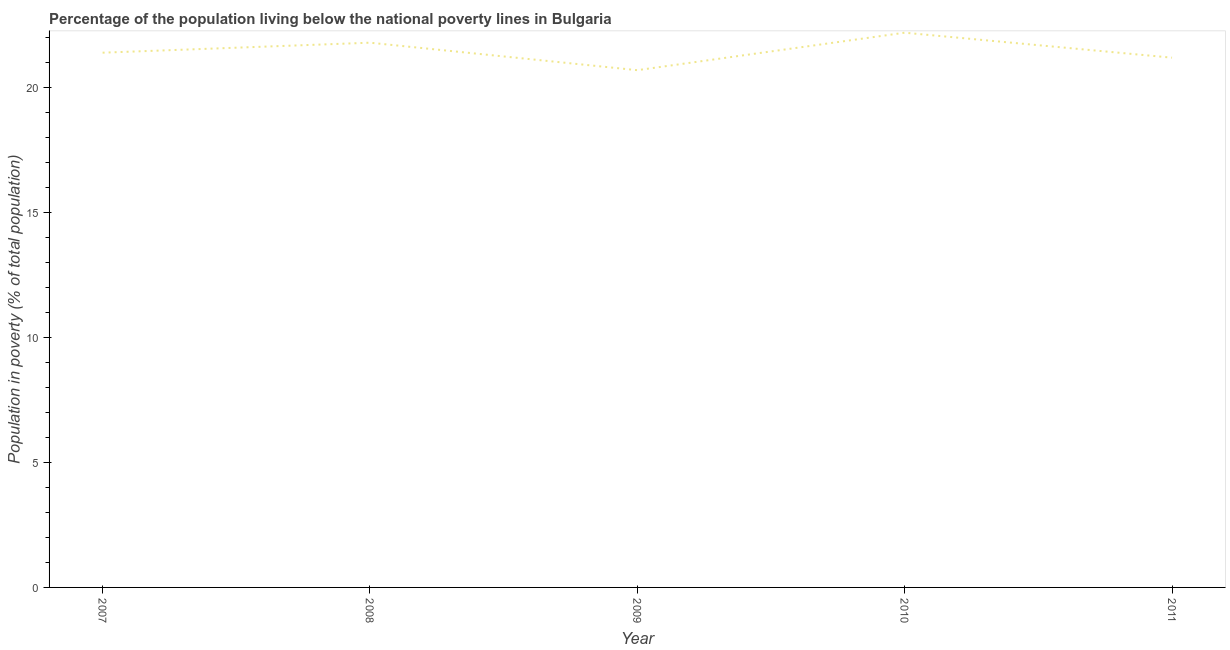What is the percentage of population living below poverty line in 2008?
Your answer should be very brief. 21.8. Across all years, what is the maximum percentage of population living below poverty line?
Keep it short and to the point. 22.2. Across all years, what is the minimum percentage of population living below poverty line?
Your response must be concise. 20.7. In which year was the percentage of population living below poverty line minimum?
Your answer should be very brief. 2009. What is the sum of the percentage of population living below poverty line?
Provide a succinct answer. 107.3. What is the average percentage of population living below poverty line per year?
Your answer should be very brief. 21.46. What is the median percentage of population living below poverty line?
Make the answer very short. 21.4. Do a majority of the years between 2009 and 2007 (inclusive) have percentage of population living below poverty line greater than 21 %?
Offer a terse response. No. What is the ratio of the percentage of population living below poverty line in 2007 to that in 2008?
Offer a terse response. 0.98. Is the difference between the percentage of population living below poverty line in 2008 and 2009 greater than the difference between any two years?
Offer a very short reply. No. What is the difference between the highest and the second highest percentage of population living below poverty line?
Ensure brevity in your answer.  0.4. In how many years, is the percentage of population living below poverty line greater than the average percentage of population living below poverty line taken over all years?
Make the answer very short. 2. Does the percentage of population living below poverty line monotonically increase over the years?
Keep it short and to the point. No. How many years are there in the graph?
Provide a succinct answer. 5. Does the graph contain any zero values?
Offer a very short reply. No. What is the title of the graph?
Your answer should be compact. Percentage of the population living below the national poverty lines in Bulgaria. What is the label or title of the X-axis?
Offer a terse response. Year. What is the label or title of the Y-axis?
Give a very brief answer. Population in poverty (% of total population). What is the Population in poverty (% of total population) of 2007?
Keep it short and to the point. 21.4. What is the Population in poverty (% of total population) in 2008?
Make the answer very short. 21.8. What is the Population in poverty (% of total population) of 2009?
Provide a succinct answer. 20.7. What is the Population in poverty (% of total population) in 2011?
Offer a very short reply. 21.2. What is the difference between the Population in poverty (% of total population) in 2007 and 2011?
Offer a terse response. 0.2. What is the difference between the Population in poverty (% of total population) in 2008 and 2011?
Provide a succinct answer. 0.6. What is the difference between the Population in poverty (% of total population) in 2010 and 2011?
Give a very brief answer. 1. What is the ratio of the Population in poverty (% of total population) in 2007 to that in 2009?
Your answer should be compact. 1.03. What is the ratio of the Population in poverty (% of total population) in 2007 to that in 2010?
Offer a very short reply. 0.96. What is the ratio of the Population in poverty (% of total population) in 2007 to that in 2011?
Your answer should be very brief. 1.01. What is the ratio of the Population in poverty (% of total population) in 2008 to that in 2009?
Make the answer very short. 1.05. What is the ratio of the Population in poverty (% of total population) in 2008 to that in 2010?
Your response must be concise. 0.98. What is the ratio of the Population in poverty (% of total population) in 2008 to that in 2011?
Provide a short and direct response. 1.03. What is the ratio of the Population in poverty (% of total population) in 2009 to that in 2010?
Give a very brief answer. 0.93. What is the ratio of the Population in poverty (% of total population) in 2010 to that in 2011?
Make the answer very short. 1.05. 